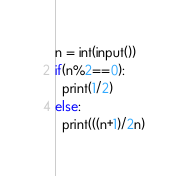<code> <loc_0><loc_0><loc_500><loc_500><_Python_>n = int(input())
if(n%2==0):
  print(1/2)
else:
  print(((n+1)/2n)</code> 